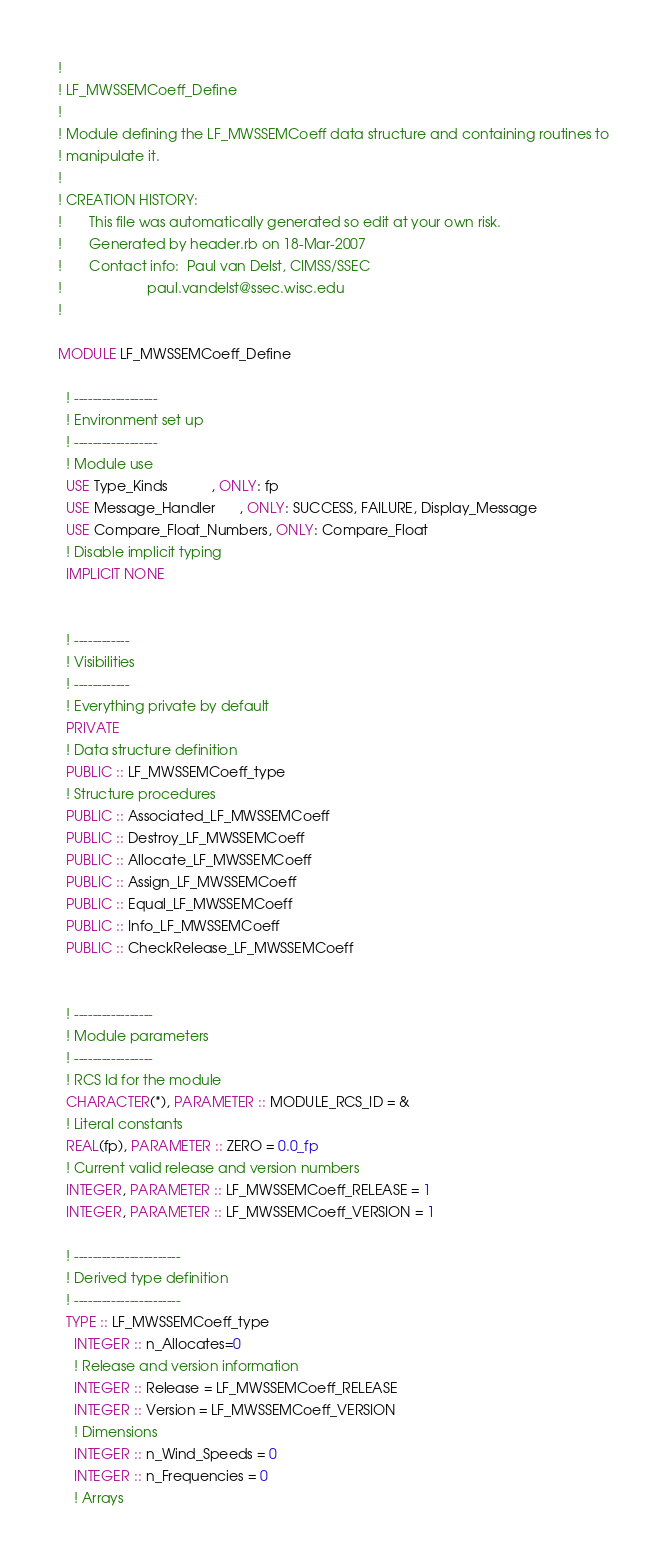<code> <loc_0><loc_0><loc_500><loc_500><_FORTRAN_>!
! LF_MWSSEMCoeff_Define
!
! Module defining the LF_MWSSEMCoeff data structure and containing routines to 
! manipulate it.
!
! CREATION HISTORY:
!       This file was automatically generated so edit at your own risk.
!       Generated by header.rb on 18-Mar-2007
!       Contact info:  Paul van Delst, CIMSS/SSEC
!                      paul.vandelst@ssec.wisc.edu
!

MODULE LF_MWSSEMCoeff_Define

  ! ------------------
  ! Environment set up
  ! ------------------
  ! Module use
  USE Type_Kinds           , ONLY: fp
  USE Message_Handler      , ONLY: SUCCESS, FAILURE, Display_Message
  USE Compare_Float_Numbers, ONLY: Compare_Float
  ! Disable implicit typing
  IMPLICIT NONE


  ! ------------
  ! Visibilities
  ! ------------
  ! Everything private by default
  PRIVATE
  ! Data structure definition
  PUBLIC :: LF_MWSSEMCoeff_type
  ! Structure procedures
  PUBLIC :: Associated_LF_MWSSEMCoeff
  PUBLIC :: Destroy_LF_MWSSEMCoeff
  PUBLIC :: Allocate_LF_MWSSEMCoeff
  PUBLIC :: Assign_LF_MWSSEMCoeff
  PUBLIC :: Equal_LF_MWSSEMCoeff
  PUBLIC :: Info_LF_MWSSEMCoeff
  PUBLIC :: CheckRelease_LF_MWSSEMCoeff
    

  ! -----------------
  ! Module parameters
  ! -----------------
  ! RCS Id for the module
  CHARACTER(*), PARAMETER :: MODULE_RCS_ID = &
  ! Literal constants
  REAL(fp), PARAMETER :: ZERO = 0.0_fp
  ! Current valid release and version numbers
  INTEGER, PARAMETER :: LF_MWSSEMCoeff_RELEASE = 1
  INTEGER, PARAMETER :: LF_MWSSEMCoeff_VERSION = 1

  ! -----------------------
  ! Derived type definition
  ! -----------------------
  TYPE :: LF_MWSSEMCoeff_type
    INTEGER :: n_Allocates=0
    ! Release and version information
    INTEGER :: Release = LF_MWSSEMCoeff_RELEASE
    INTEGER :: Version = LF_MWSSEMCoeff_VERSION
    ! Dimensions
    INTEGER :: n_Wind_Speeds = 0
    INTEGER :: n_Frequencies = 0
    ! Arrays</code> 